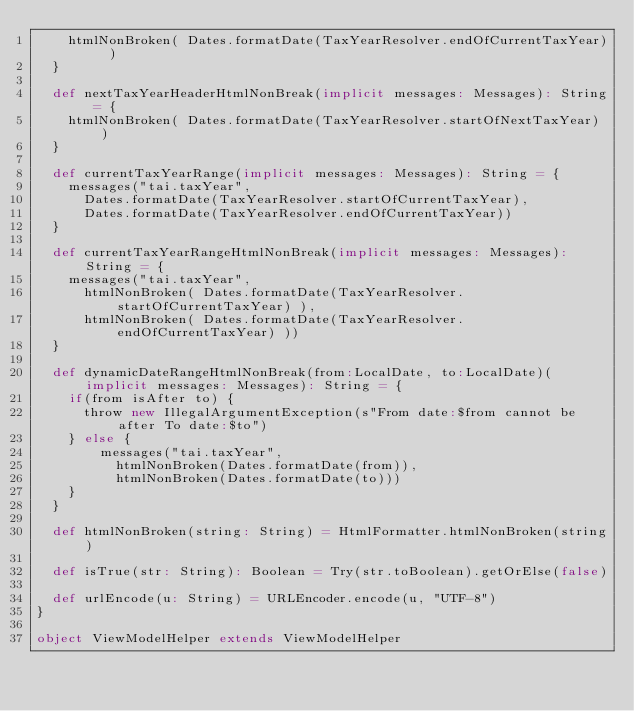<code> <loc_0><loc_0><loc_500><loc_500><_Scala_>    htmlNonBroken( Dates.formatDate(TaxYearResolver.endOfCurrentTaxYear) )
  }

  def nextTaxYearHeaderHtmlNonBreak(implicit messages: Messages): String = {
    htmlNonBroken( Dates.formatDate(TaxYearResolver.startOfNextTaxYear) )
  }

  def currentTaxYearRange(implicit messages: Messages): String = {
    messages("tai.taxYear",
      Dates.formatDate(TaxYearResolver.startOfCurrentTaxYear),
      Dates.formatDate(TaxYearResolver.endOfCurrentTaxYear))
  }

  def currentTaxYearRangeHtmlNonBreak(implicit messages: Messages): String = {
    messages("tai.taxYear",
      htmlNonBroken( Dates.formatDate(TaxYearResolver.startOfCurrentTaxYear) ),
      htmlNonBroken( Dates.formatDate(TaxYearResolver.endOfCurrentTaxYear) ))
  }

  def dynamicDateRangeHtmlNonBreak(from:LocalDate, to:LocalDate)(implicit messages: Messages): String = {
    if(from isAfter to) {
      throw new IllegalArgumentException(s"From date:$from cannot be after To date:$to")
    } else {
        messages("tai.taxYear",
          htmlNonBroken(Dates.formatDate(from)),
          htmlNonBroken(Dates.formatDate(to)))
    }
  }

  def htmlNonBroken(string: String) = HtmlFormatter.htmlNonBroken(string)

  def isTrue(str: String): Boolean = Try(str.toBoolean).getOrElse(false)

  def urlEncode(u: String) = URLEncoder.encode(u, "UTF-8")
}

object ViewModelHelper extends ViewModelHelper
</code> 